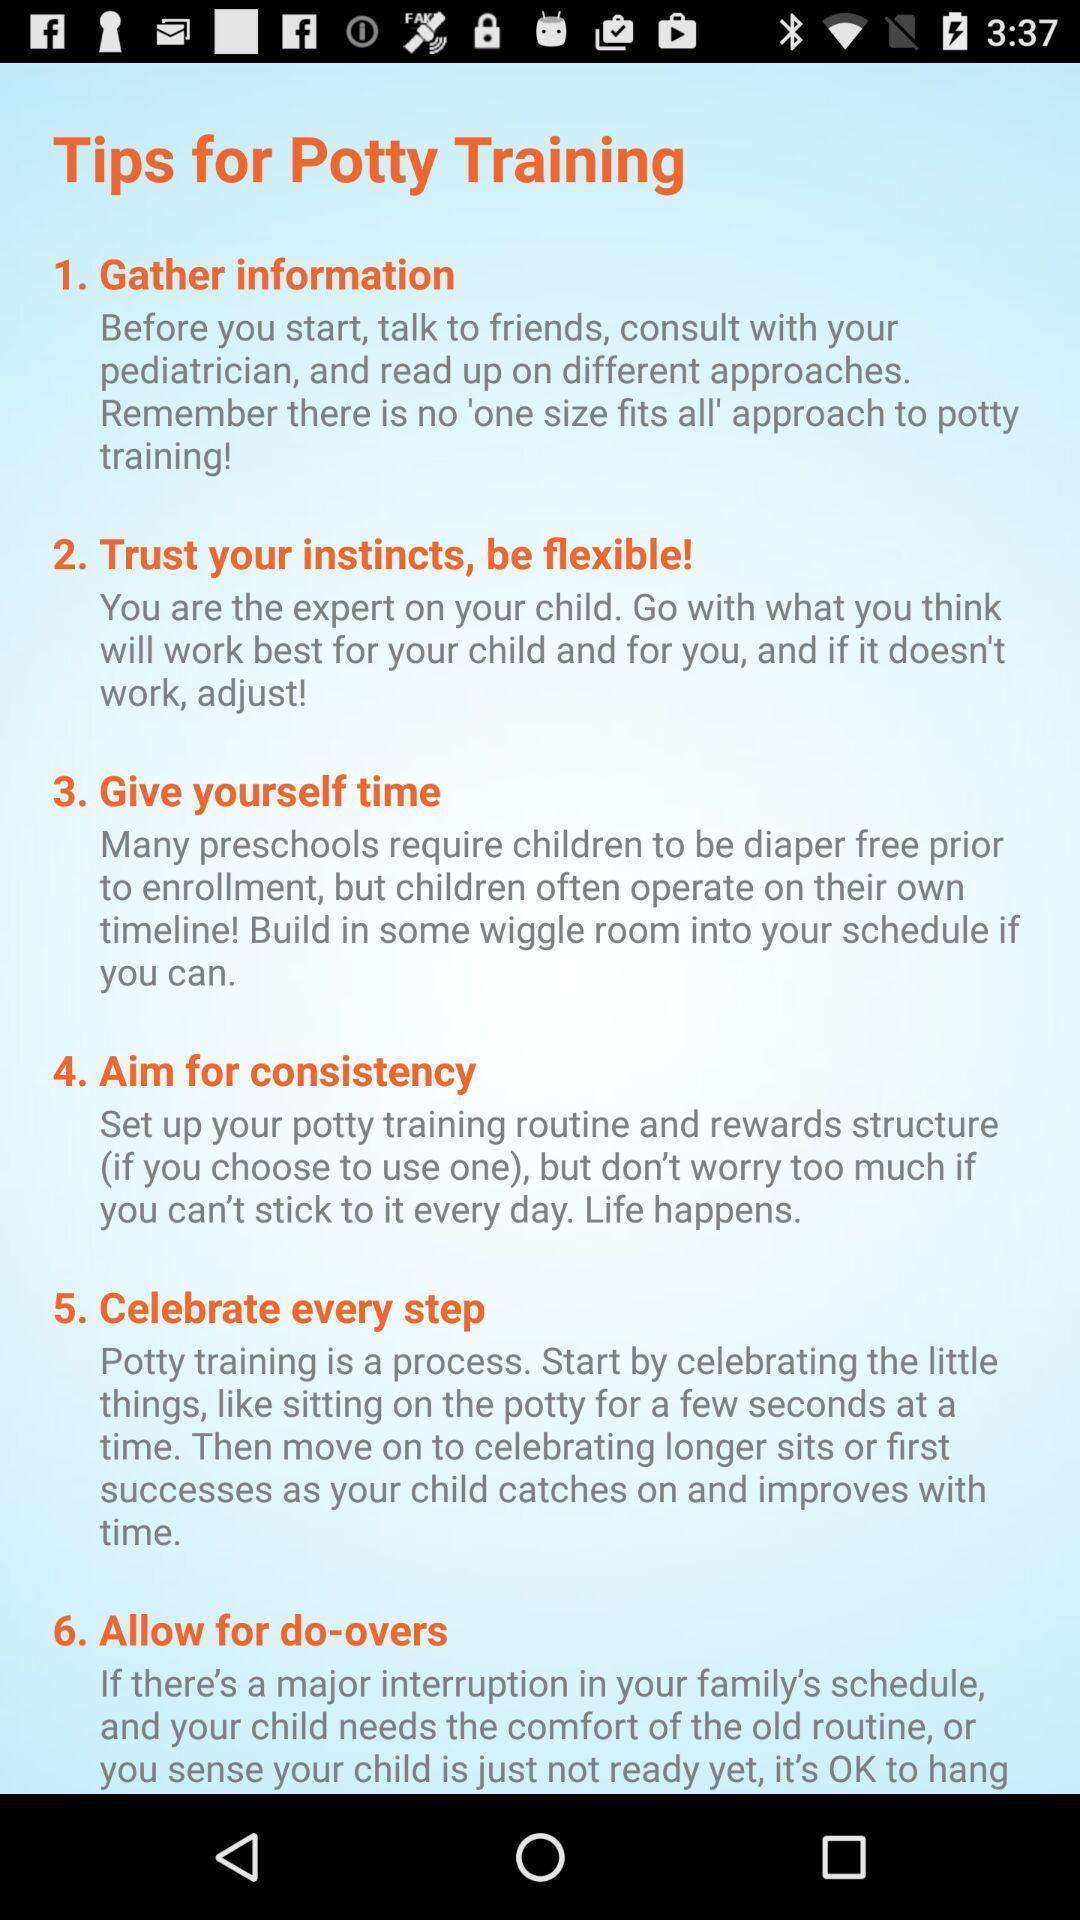Give me a summary of this screen capture. Page showing various tips for training. 